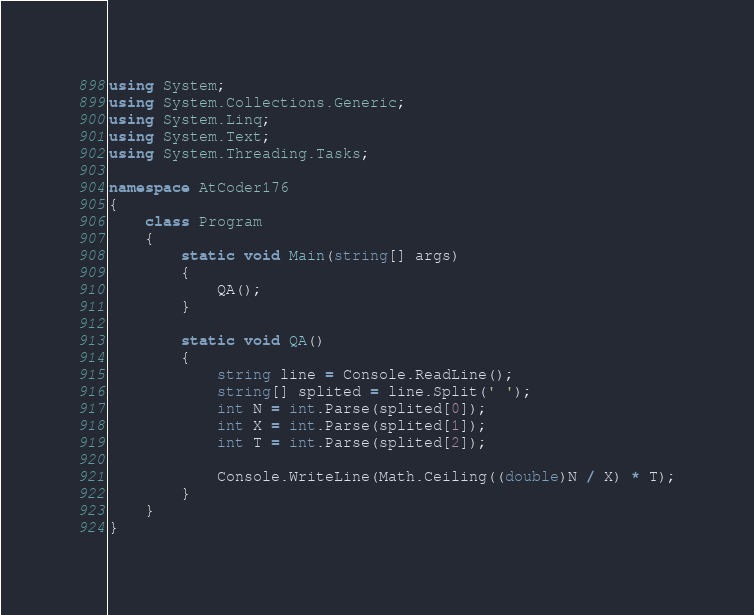<code> <loc_0><loc_0><loc_500><loc_500><_C#_>using System;
using System.Collections.Generic;
using System.Linq;
using System.Text;
using System.Threading.Tasks;

namespace AtCoder176
{
    class Program
    {
        static void Main(string[] args)
        {
            QA();
        }

        static void QA()
        {
            string line = Console.ReadLine();
            string[] splited = line.Split(' ');
            int N = int.Parse(splited[0]);
            int X = int.Parse(splited[1]);
            int T = int.Parse(splited[2]);

            Console.WriteLine(Math.Ceiling((double)N / X) * T);
        }
    }
}
</code> 